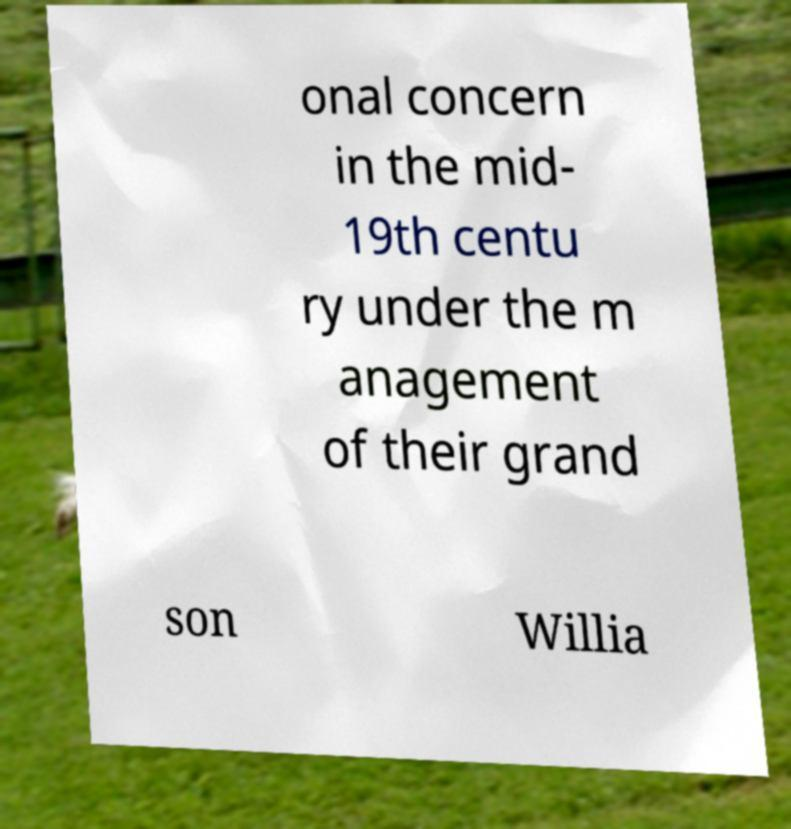What messages or text are displayed in this image? I need them in a readable, typed format. onal concern in the mid- 19th centu ry under the m anagement of their grand son Willia 